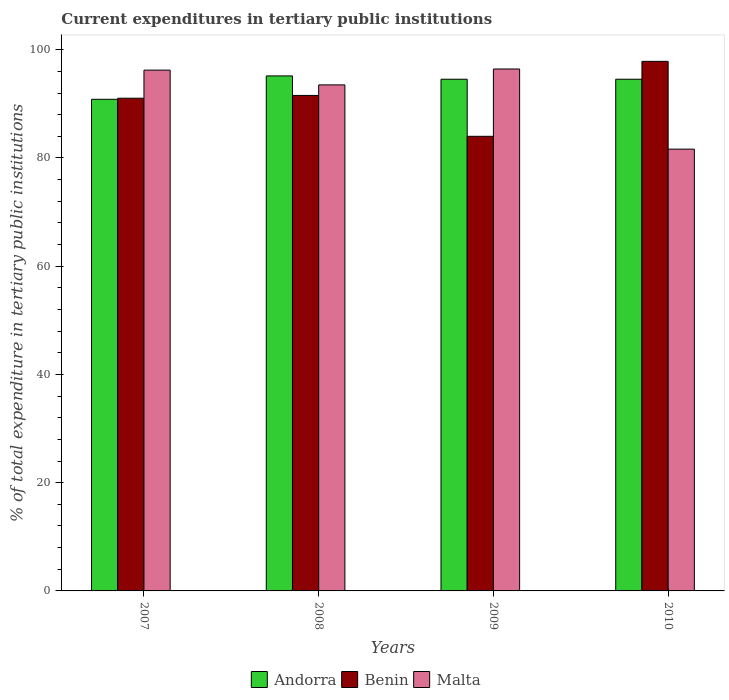Are the number of bars per tick equal to the number of legend labels?
Your answer should be very brief. Yes. How many bars are there on the 1st tick from the left?
Ensure brevity in your answer.  3. What is the current expenditures in tertiary public institutions in Andorra in 2010?
Provide a short and direct response. 94.55. Across all years, what is the maximum current expenditures in tertiary public institutions in Malta?
Offer a terse response. 96.44. Across all years, what is the minimum current expenditures in tertiary public institutions in Benin?
Make the answer very short. 84. In which year was the current expenditures in tertiary public institutions in Andorra minimum?
Offer a very short reply. 2007. What is the total current expenditures in tertiary public institutions in Malta in the graph?
Offer a terse response. 367.81. What is the difference between the current expenditures in tertiary public institutions in Benin in 2008 and that in 2010?
Ensure brevity in your answer.  -6.3. What is the difference between the current expenditures in tertiary public institutions in Benin in 2007 and the current expenditures in tertiary public institutions in Andorra in 2008?
Ensure brevity in your answer.  -4.12. What is the average current expenditures in tertiary public institutions in Benin per year?
Keep it short and to the point. 91.11. In the year 2008, what is the difference between the current expenditures in tertiary public institutions in Benin and current expenditures in tertiary public institutions in Malta?
Keep it short and to the point. -1.95. In how many years, is the current expenditures in tertiary public institutions in Andorra greater than 56 %?
Your answer should be very brief. 4. What is the ratio of the current expenditures in tertiary public institutions in Malta in 2007 to that in 2008?
Provide a succinct answer. 1.03. Is the difference between the current expenditures in tertiary public institutions in Benin in 2008 and 2010 greater than the difference between the current expenditures in tertiary public institutions in Malta in 2008 and 2010?
Give a very brief answer. No. What is the difference between the highest and the second highest current expenditures in tertiary public institutions in Benin?
Your answer should be very brief. 6.3. What is the difference between the highest and the lowest current expenditures in tertiary public institutions in Benin?
Your answer should be compact. 13.85. In how many years, is the current expenditures in tertiary public institutions in Andorra greater than the average current expenditures in tertiary public institutions in Andorra taken over all years?
Your answer should be compact. 3. Is the sum of the current expenditures in tertiary public institutions in Benin in 2008 and 2010 greater than the maximum current expenditures in tertiary public institutions in Malta across all years?
Provide a succinct answer. Yes. What does the 1st bar from the left in 2007 represents?
Your answer should be very brief. Andorra. What does the 3rd bar from the right in 2010 represents?
Offer a very short reply. Andorra. How many bars are there?
Give a very brief answer. 12. How many years are there in the graph?
Provide a succinct answer. 4. What is the difference between two consecutive major ticks on the Y-axis?
Your answer should be very brief. 20. Does the graph contain any zero values?
Offer a very short reply. No. Where does the legend appear in the graph?
Offer a terse response. Bottom center. How many legend labels are there?
Provide a short and direct response. 3. How are the legend labels stacked?
Your answer should be very brief. Horizontal. What is the title of the graph?
Provide a succinct answer. Current expenditures in tertiary public institutions. What is the label or title of the Y-axis?
Provide a short and direct response. % of total expenditure in tertiary public institutions. What is the % of total expenditure in tertiary public institutions of Andorra in 2007?
Your answer should be compact. 90.84. What is the % of total expenditure in tertiary public institutions of Benin in 2007?
Offer a very short reply. 91.04. What is the % of total expenditure in tertiary public institutions of Malta in 2007?
Make the answer very short. 96.23. What is the % of total expenditure in tertiary public institutions in Andorra in 2008?
Provide a succinct answer. 95.16. What is the % of total expenditure in tertiary public institutions in Benin in 2008?
Provide a succinct answer. 91.56. What is the % of total expenditure in tertiary public institutions of Malta in 2008?
Make the answer very short. 93.5. What is the % of total expenditure in tertiary public institutions in Andorra in 2009?
Give a very brief answer. 94.55. What is the % of total expenditure in tertiary public institutions in Benin in 2009?
Your response must be concise. 84. What is the % of total expenditure in tertiary public institutions in Malta in 2009?
Your response must be concise. 96.44. What is the % of total expenditure in tertiary public institutions of Andorra in 2010?
Offer a terse response. 94.55. What is the % of total expenditure in tertiary public institutions of Benin in 2010?
Your answer should be compact. 97.85. What is the % of total expenditure in tertiary public institutions of Malta in 2010?
Provide a succinct answer. 81.63. Across all years, what is the maximum % of total expenditure in tertiary public institutions of Andorra?
Your answer should be very brief. 95.16. Across all years, what is the maximum % of total expenditure in tertiary public institutions of Benin?
Your response must be concise. 97.85. Across all years, what is the maximum % of total expenditure in tertiary public institutions of Malta?
Provide a short and direct response. 96.44. Across all years, what is the minimum % of total expenditure in tertiary public institutions in Andorra?
Ensure brevity in your answer.  90.84. Across all years, what is the minimum % of total expenditure in tertiary public institutions in Benin?
Ensure brevity in your answer.  84. Across all years, what is the minimum % of total expenditure in tertiary public institutions of Malta?
Keep it short and to the point. 81.63. What is the total % of total expenditure in tertiary public institutions in Andorra in the graph?
Offer a terse response. 375.11. What is the total % of total expenditure in tertiary public institutions of Benin in the graph?
Make the answer very short. 364.45. What is the total % of total expenditure in tertiary public institutions of Malta in the graph?
Offer a terse response. 367.81. What is the difference between the % of total expenditure in tertiary public institutions of Andorra in 2007 and that in 2008?
Provide a succinct answer. -4.32. What is the difference between the % of total expenditure in tertiary public institutions in Benin in 2007 and that in 2008?
Your answer should be compact. -0.52. What is the difference between the % of total expenditure in tertiary public institutions of Malta in 2007 and that in 2008?
Provide a short and direct response. 2.73. What is the difference between the % of total expenditure in tertiary public institutions in Andorra in 2007 and that in 2009?
Give a very brief answer. -3.71. What is the difference between the % of total expenditure in tertiary public institutions of Benin in 2007 and that in 2009?
Make the answer very short. 7.04. What is the difference between the % of total expenditure in tertiary public institutions of Malta in 2007 and that in 2009?
Your answer should be very brief. -0.21. What is the difference between the % of total expenditure in tertiary public institutions of Andorra in 2007 and that in 2010?
Your answer should be compact. -3.71. What is the difference between the % of total expenditure in tertiary public institutions in Benin in 2007 and that in 2010?
Provide a short and direct response. -6.81. What is the difference between the % of total expenditure in tertiary public institutions of Malta in 2007 and that in 2010?
Give a very brief answer. 14.6. What is the difference between the % of total expenditure in tertiary public institutions of Andorra in 2008 and that in 2009?
Your answer should be very brief. 0.61. What is the difference between the % of total expenditure in tertiary public institutions of Benin in 2008 and that in 2009?
Provide a succinct answer. 7.55. What is the difference between the % of total expenditure in tertiary public institutions of Malta in 2008 and that in 2009?
Offer a terse response. -2.94. What is the difference between the % of total expenditure in tertiary public institutions in Andorra in 2008 and that in 2010?
Your answer should be compact. 0.61. What is the difference between the % of total expenditure in tertiary public institutions of Benin in 2008 and that in 2010?
Your answer should be very brief. -6.3. What is the difference between the % of total expenditure in tertiary public institutions in Malta in 2008 and that in 2010?
Your answer should be very brief. 11.87. What is the difference between the % of total expenditure in tertiary public institutions of Benin in 2009 and that in 2010?
Give a very brief answer. -13.85. What is the difference between the % of total expenditure in tertiary public institutions in Malta in 2009 and that in 2010?
Your answer should be compact. 14.81. What is the difference between the % of total expenditure in tertiary public institutions in Andorra in 2007 and the % of total expenditure in tertiary public institutions in Benin in 2008?
Make the answer very short. -0.71. What is the difference between the % of total expenditure in tertiary public institutions of Andorra in 2007 and the % of total expenditure in tertiary public institutions of Malta in 2008?
Provide a short and direct response. -2.66. What is the difference between the % of total expenditure in tertiary public institutions in Benin in 2007 and the % of total expenditure in tertiary public institutions in Malta in 2008?
Your response must be concise. -2.47. What is the difference between the % of total expenditure in tertiary public institutions in Andorra in 2007 and the % of total expenditure in tertiary public institutions in Benin in 2009?
Offer a very short reply. 6.84. What is the difference between the % of total expenditure in tertiary public institutions of Andorra in 2007 and the % of total expenditure in tertiary public institutions of Malta in 2009?
Keep it short and to the point. -5.6. What is the difference between the % of total expenditure in tertiary public institutions in Benin in 2007 and the % of total expenditure in tertiary public institutions in Malta in 2009?
Your answer should be very brief. -5.4. What is the difference between the % of total expenditure in tertiary public institutions in Andorra in 2007 and the % of total expenditure in tertiary public institutions in Benin in 2010?
Offer a terse response. -7.01. What is the difference between the % of total expenditure in tertiary public institutions in Andorra in 2007 and the % of total expenditure in tertiary public institutions in Malta in 2010?
Keep it short and to the point. 9.21. What is the difference between the % of total expenditure in tertiary public institutions of Benin in 2007 and the % of total expenditure in tertiary public institutions of Malta in 2010?
Your response must be concise. 9.4. What is the difference between the % of total expenditure in tertiary public institutions of Andorra in 2008 and the % of total expenditure in tertiary public institutions of Benin in 2009?
Offer a terse response. 11.16. What is the difference between the % of total expenditure in tertiary public institutions in Andorra in 2008 and the % of total expenditure in tertiary public institutions in Malta in 2009?
Offer a terse response. -1.28. What is the difference between the % of total expenditure in tertiary public institutions of Benin in 2008 and the % of total expenditure in tertiary public institutions of Malta in 2009?
Keep it short and to the point. -4.89. What is the difference between the % of total expenditure in tertiary public institutions in Andorra in 2008 and the % of total expenditure in tertiary public institutions in Benin in 2010?
Give a very brief answer. -2.69. What is the difference between the % of total expenditure in tertiary public institutions of Andorra in 2008 and the % of total expenditure in tertiary public institutions of Malta in 2010?
Your answer should be compact. 13.53. What is the difference between the % of total expenditure in tertiary public institutions of Benin in 2008 and the % of total expenditure in tertiary public institutions of Malta in 2010?
Your answer should be compact. 9.92. What is the difference between the % of total expenditure in tertiary public institutions of Andorra in 2009 and the % of total expenditure in tertiary public institutions of Benin in 2010?
Your answer should be compact. -3.3. What is the difference between the % of total expenditure in tertiary public institutions in Andorra in 2009 and the % of total expenditure in tertiary public institutions in Malta in 2010?
Provide a succinct answer. 12.92. What is the difference between the % of total expenditure in tertiary public institutions in Benin in 2009 and the % of total expenditure in tertiary public institutions in Malta in 2010?
Offer a terse response. 2.37. What is the average % of total expenditure in tertiary public institutions in Andorra per year?
Ensure brevity in your answer.  93.78. What is the average % of total expenditure in tertiary public institutions of Benin per year?
Provide a short and direct response. 91.11. What is the average % of total expenditure in tertiary public institutions of Malta per year?
Keep it short and to the point. 91.95. In the year 2007, what is the difference between the % of total expenditure in tertiary public institutions in Andorra and % of total expenditure in tertiary public institutions in Benin?
Your answer should be compact. -0.19. In the year 2007, what is the difference between the % of total expenditure in tertiary public institutions in Andorra and % of total expenditure in tertiary public institutions in Malta?
Offer a terse response. -5.39. In the year 2007, what is the difference between the % of total expenditure in tertiary public institutions of Benin and % of total expenditure in tertiary public institutions of Malta?
Provide a succinct answer. -5.19. In the year 2008, what is the difference between the % of total expenditure in tertiary public institutions of Andorra and % of total expenditure in tertiary public institutions of Benin?
Provide a short and direct response. 3.61. In the year 2008, what is the difference between the % of total expenditure in tertiary public institutions of Andorra and % of total expenditure in tertiary public institutions of Malta?
Your answer should be compact. 1.66. In the year 2008, what is the difference between the % of total expenditure in tertiary public institutions of Benin and % of total expenditure in tertiary public institutions of Malta?
Your answer should be compact. -1.95. In the year 2009, what is the difference between the % of total expenditure in tertiary public institutions in Andorra and % of total expenditure in tertiary public institutions in Benin?
Keep it short and to the point. 10.55. In the year 2009, what is the difference between the % of total expenditure in tertiary public institutions in Andorra and % of total expenditure in tertiary public institutions in Malta?
Offer a very short reply. -1.89. In the year 2009, what is the difference between the % of total expenditure in tertiary public institutions in Benin and % of total expenditure in tertiary public institutions in Malta?
Provide a succinct answer. -12.44. In the year 2010, what is the difference between the % of total expenditure in tertiary public institutions in Andorra and % of total expenditure in tertiary public institutions in Benin?
Ensure brevity in your answer.  -3.3. In the year 2010, what is the difference between the % of total expenditure in tertiary public institutions of Andorra and % of total expenditure in tertiary public institutions of Malta?
Make the answer very short. 12.92. In the year 2010, what is the difference between the % of total expenditure in tertiary public institutions of Benin and % of total expenditure in tertiary public institutions of Malta?
Your answer should be compact. 16.22. What is the ratio of the % of total expenditure in tertiary public institutions of Andorra in 2007 to that in 2008?
Give a very brief answer. 0.95. What is the ratio of the % of total expenditure in tertiary public institutions of Malta in 2007 to that in 2008?
Give a very brief answer. 1.03. What is the ratio of the % of total expenditure in tertiary public institutions of Andorra in 2007 to that in 2009?
Your response must be concise. 0.96. What is the ratio of the % of total expenditure in tertiary public institutions in Benin in 2007 to that in 2009?
Provide a short and direct response. 1.08. What is the ratio of the % of total expenditure in tertiary public institutions of Andorra in 2007 to that in 2010?
Provide a succinct answer. 0.96. What is the ratio of the % of total expenditure in tertiary public institutions in Benin in 2007 to that in 2010?
Ensure brevity in your answer.  0.93. What is the ratio of the % of total expenditure in tertiary public institutions of Malta in 2007 to that in 2010?
Offer a terse response. 1.18. What is the ratio of the % of total expenditure in tertiary public institutions in Andorra in 2008 to that in 2009?
Your answer should be compact. 1.01. What is the ratio of the % of total expenditure in tertiary public institutions in Benin in 2008 to that in 2009?
Offer a very short reply. 1.09. What is the ratio of the % of total expenditure in tertiary public institutions of Malta in 2008 to that in 2009?
Provide a succinct answer. 0.97. What is the ratio of the % of total expenditure in tertiary public institutions in Andorra in 2008 to that in 2010?
Offer a terse response. 1.01. What is the ratio of the % of total expenditure in tertiary public institutions in Benin in 2008 to that in 2010?
Offer a terse response. 0.94. What is the ratio of the % of total expenditure in tertiary public institutions in Malta in 2008 to that in 2010?
Offer a very short reply. 1.15. What is the ratio of the % of total expenditure in tertiary public institutions in Benin in 2009 to that in 2010?
Offer a terse response. 0.86. What is the ratio of the % of total expenditure in tertiary public institutions in Malta in 2009 to that in 2010?
Offer a very short reply. 1.18. What is the difference between the highest and the second highest % of total expenditure in tertiary public institutions in Andorra?
Keep it short and to the point. 0.61. What is the difference between the highest and the second highest % of total expenditure in tertiary public institutions of Benin?
Your answer should be very brief. 6.3. What is the difference between the highest and the second highest % of total expenditure in tertiary public institutions in Malta?
Ensure brevity in your answer.  0.21. What is the difference between the highest and the lowest % of total expenditure in tertiary public institutions in Andorra?
Make the answer very short. 4.32. What is the difference between the highest and the lowest % of total expenditure in tertiary public institutions of Benin?
Your answer should be very brief. 13.85. What is the difference between the highest and the lowest % of total expenditure in tertiary public institutions in Malta?
Keep it short and to the point. 14.81. 